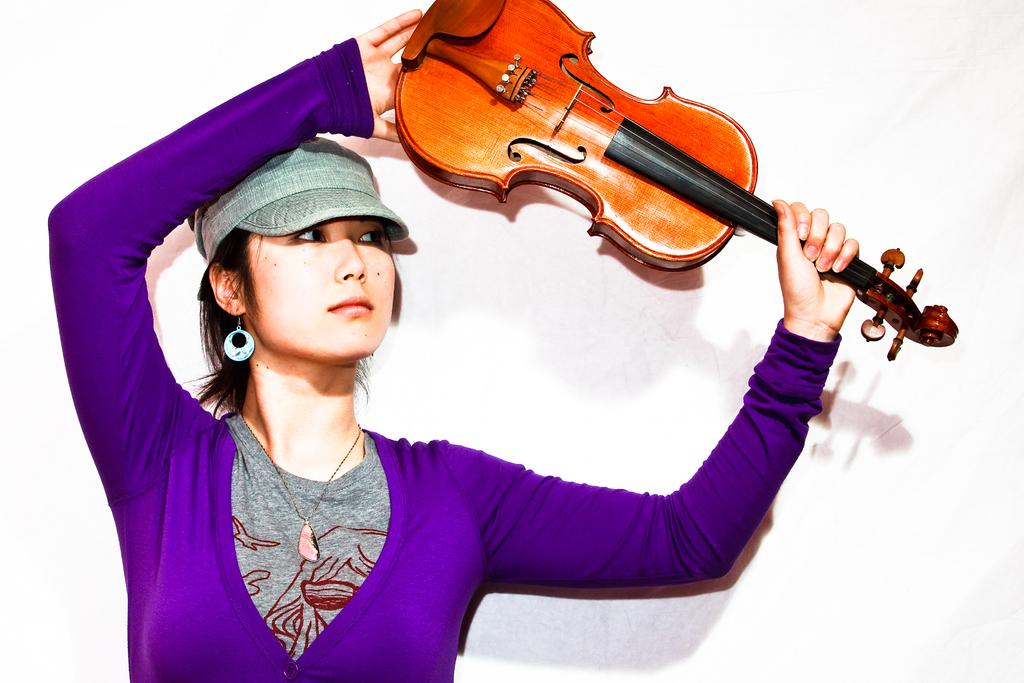What is the main subject of the image? The main subject of the image is a woman. What is the woman holding in the image? The woman is holding a guitar. How many breaths can be heard coming from the guitar in the image? There are no breaths associated with the guitar in the image, as it is an inanimate object. 